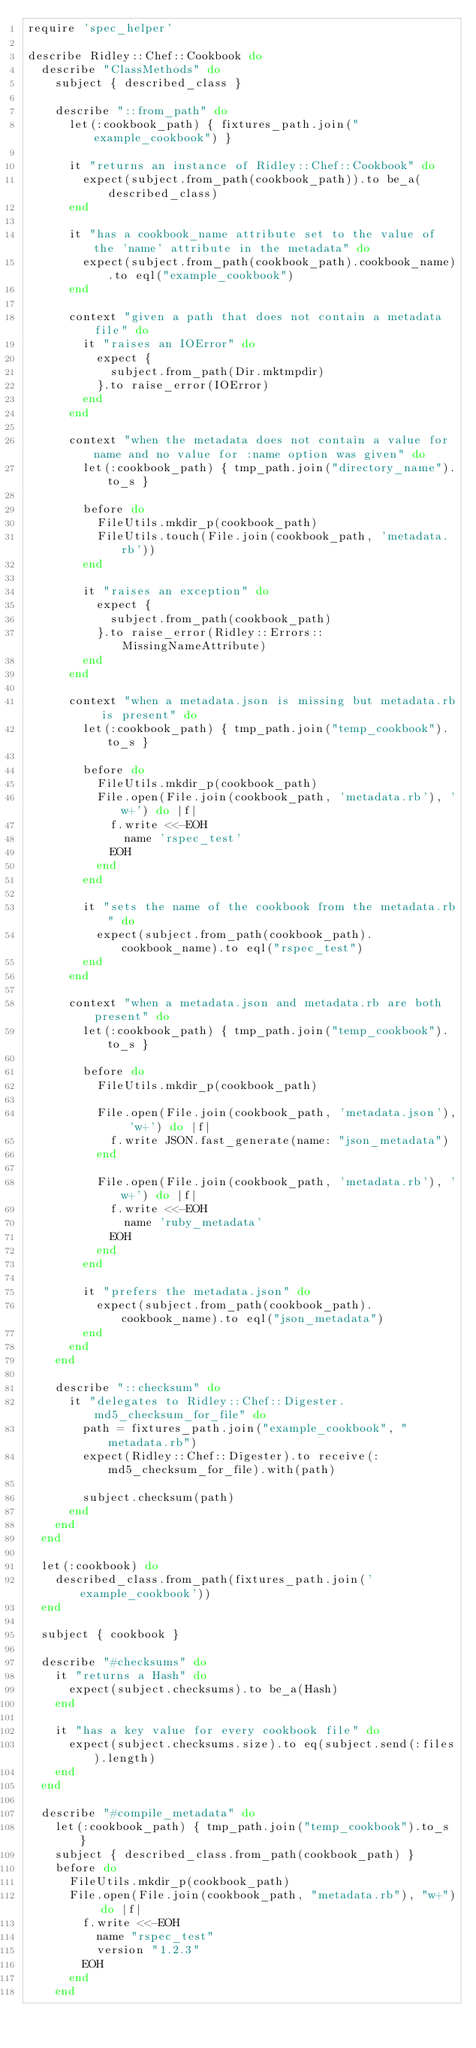<code> <loc_0><loc_0><loc_500><loc_500><_Ruby_>require 'spec_helper'

describe Ridley::Chef::Cookbook do
  describe "ClassMethods" do
    subject { described_class }

    describe "::from_path" do
      let(:cookbook_path) { fixtures_path.join("example_cookbook") }

      it "returns an instance of Ridley::Chef::Cookbook" do
        expect(subject.from_path(cookbook_path)).to be_a(described_class)
      end

      it "has a cookbook_name attribute set to the value of the 'name' attribute in the metadata" do
        expect(subject.from_path(cookbook_path).cookbook_name).to eql("example_cookbook")
      end

      context "given a path that does not contain a metadata file" do
        it "raises an IOError" do
          expect {
            subject.from_path(Dir.mktmpdir)
          }.to raise_error(IOError)
        end
      end

      context "when the metadata does not contain a value for name and no value for :name option was given" do
        let(:cookbook_path) { tmp_path.join("directory_name").to_s }

        before do
          FileUtils.mkdir_p(cookbook_path)
          FileUtils.touch(File.join(cookbook_path, 'metadata.rb'))
        end

        it "raises an exception" do
          expect {
            subject.from_path(cookbook_path)
          }.to raise_error(Ridley::Errors::MissingNameAttribute)
        end
      end

      context "when a metadata.json is missing but metadata.rb is present" do
        let(:cookbook_path) { tmp_path.join("temp_cookbook").to_s }

        before do
          FileUtils.mkdir_p(cookbook_path)
          File.open(File.join(cookbook_path, 'metadata.rb'), 'w+') do |f|
            f.write <<-EOH
              name 'rspec_test'
            EOH
          end
        end

        it "sets the name of the cookbook from the metadata.rb" do
          expect(subject.from_path(cookbook_path).cookbook_name).to eql("rspec_test")
        end
      end

      context "when a metadata.json and metadata.rb are both present" do
        let(:cookbook_path) { tmp_path.join("temp_cookbook").to_s }

        before do
          FileUtils.mkdir_p(cookbook_path)

          File.open(File.join(cookbook_path, 'metadata.json'), 'w+') do |f|
            f.write JSON.fast_generate(name: "json_metadata")
          end

          File.open(File.join(cookbook_path, 'metadata.rb'), 'w+') do |f|
            f.write <<-EOH
              name 'ruby_metadata'
            EOH
          end
        end

        it "prefers the metadata.json" do
          expect(subject.from_path(cookbook_path).cookbook_name).to eql("json_metadata")
        end
      end
    end

    describe "::checksum" do
      it "delegates to Ridley::Chef::Digester.md5_checksum_for_file" do
        path = fixtures_path.join("example_cookbook", "metadata.rb")
        expect(Ridley::Chef::Digester).to receive(:md5_checksum_for_file).with(path)

        subject.checksum(path)
      end
    end
  end

  let(:cookbook) do
    described_class.from_path(fixtures_path.join('example_cookbook'))
  end

  subject { cookbook }

  describe "#checksums" do
    it "returns a Hash" do
      expect(subject.checksums).to be_a(Hash)
    end

    it "has a key value for every cookbook file" do
      expect(subject.checksums.size).to eq(subject.send(:files).length)
    end
  end

  describe "#compile_metadata" do
    let(:cookbook_path) { tmp_path.join("temp_cookbook").to_s }
    subject { described_class.from_path(cookbook_path) }
    before do
      FileUtils.mkdir_p(cookbook_path)
      File.open(File.join(cookbook_path, "metadata.rb"), "w+") do |f|
        f.write <<-EOH
          name "rspec_test"
          version "1.2.3"
        EOH
      end
    end
</code> 